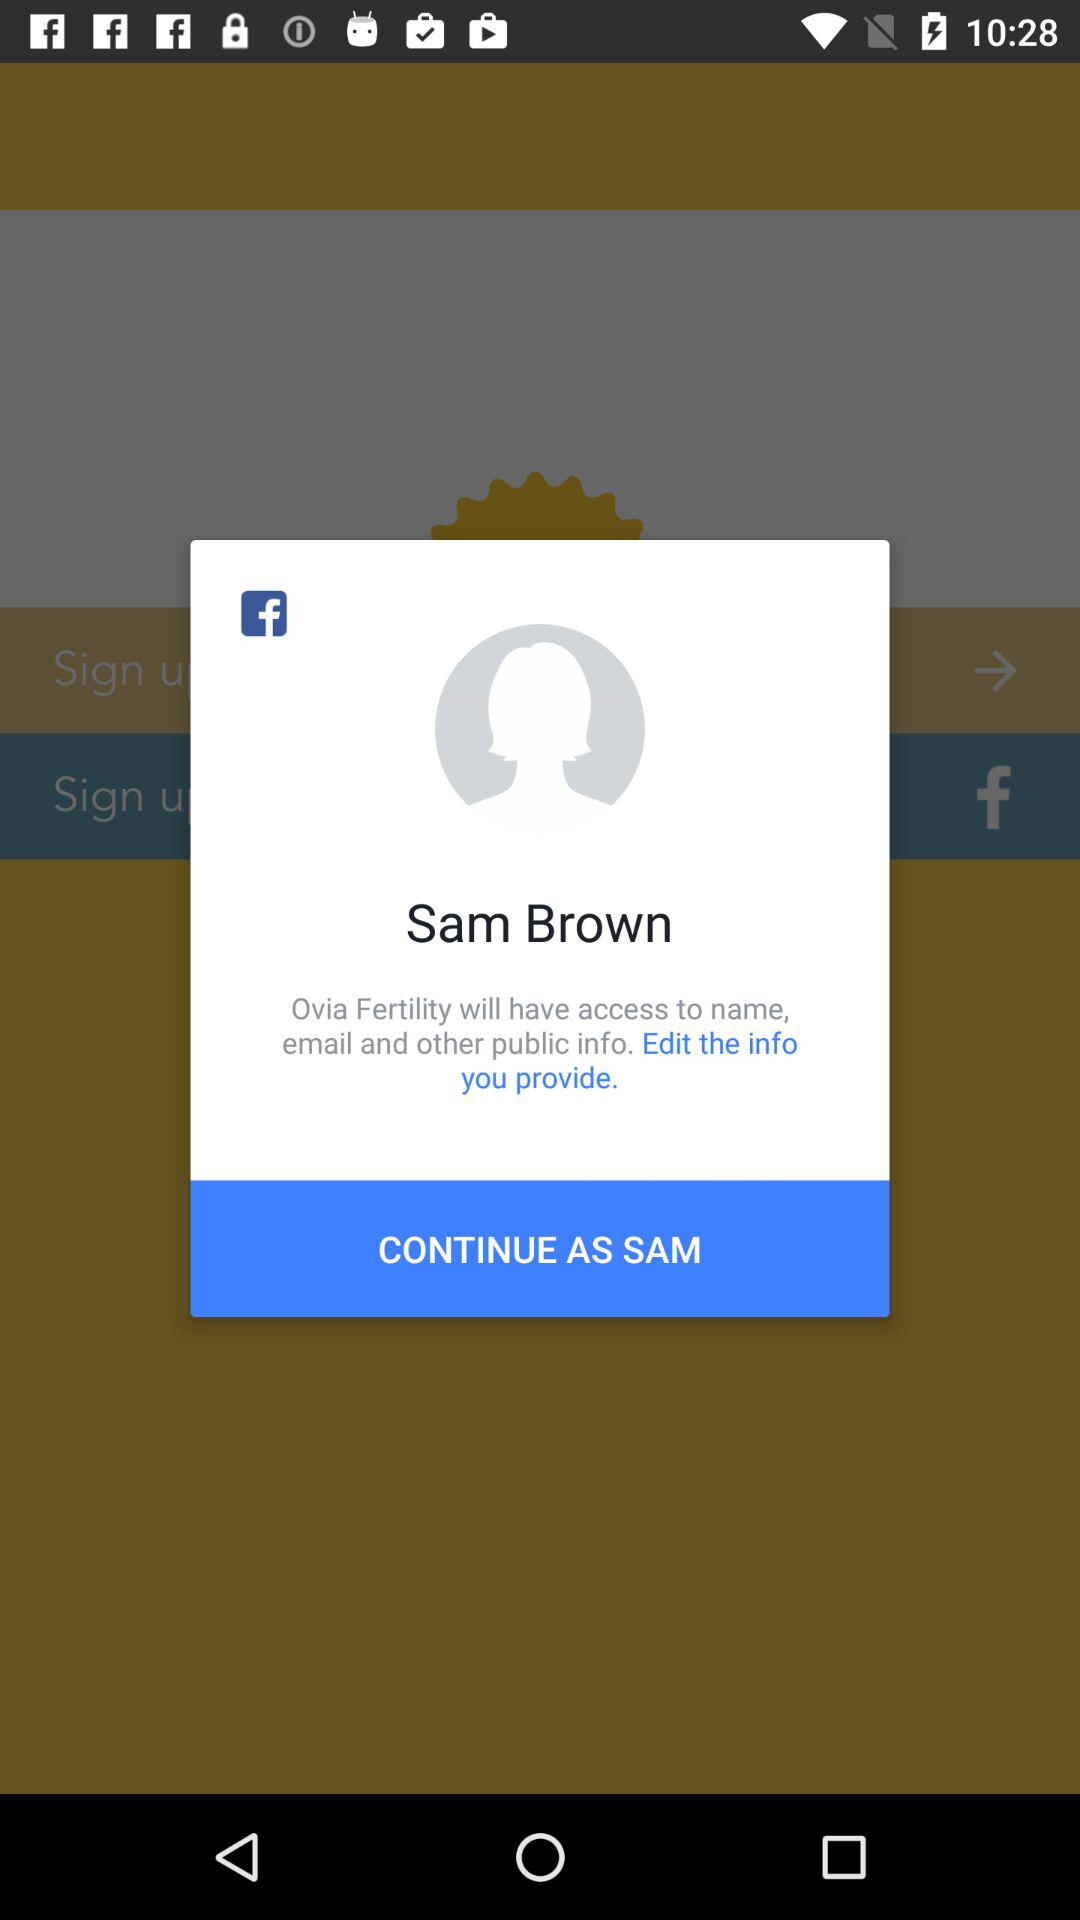What is the login name? The login name is Sam. 